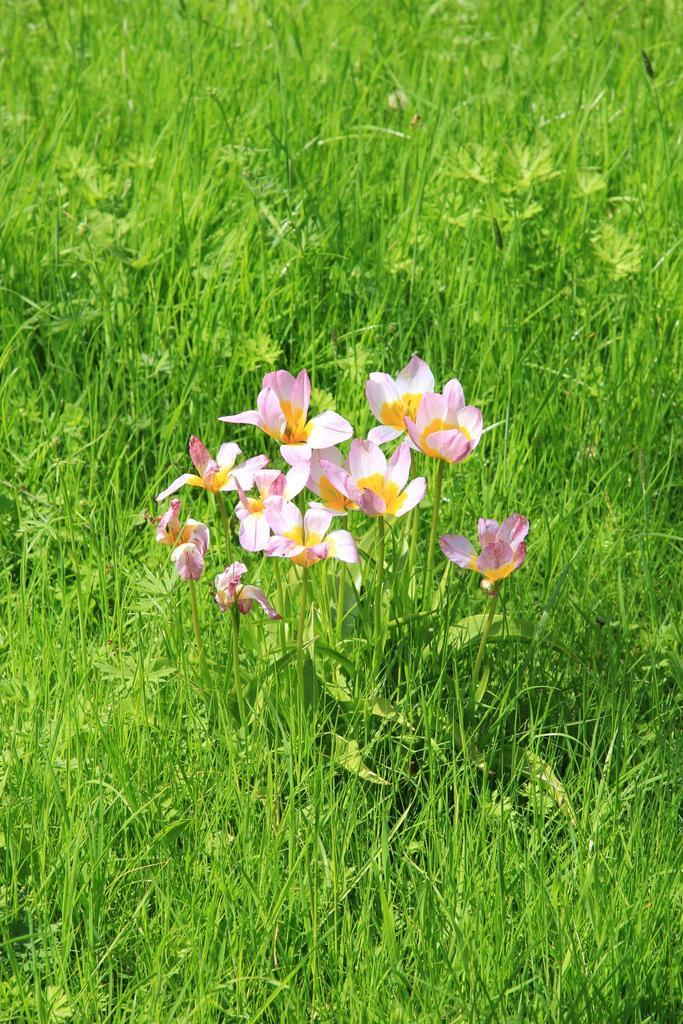What type of vegetation can be seen in the image? There is grass in the image. What can be found in the middle of the image? There are flowers in the middle of the image. What type of polish is being applied to the flowers in the image? There is no indication in the image that any polish is being applied to the flowers. 